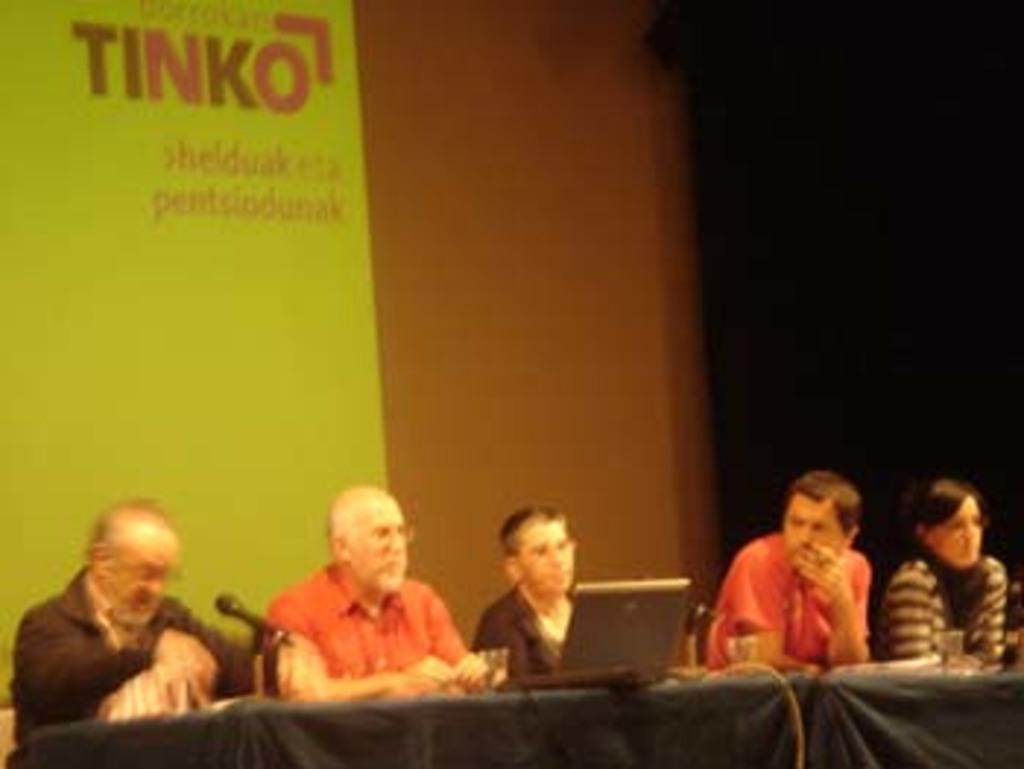What are the people in the image doing? The persons are sitting in front of a table in the image. What objects can be seen on the table? There is a mic and a laptop on the table. What additional detail is visible in the image? There is a banner visible in the image. Where might this scene be taking place? The scene appears to be on a stage. What type of plastic produce is being sold on the stage in the image? There is no plastic produce being sold in the image; the scene appears to be on a stage with persons sitting at a table, a mic, a laptop, and a banner. 